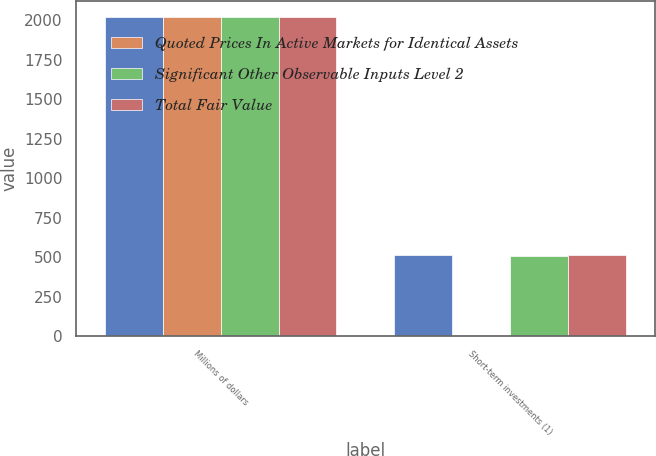Convert chart. <chart><loc_0><loc_0><loc_500><loc_500><stacked_bar_chart><ecel><fcel>Millions of dollars<fcel>Short-term investments (1)<nl><fcel>nan<fcel>2018<fcel>511<nl><fcel>Quoted Prices In Active Markets for Identical Assets<fcel>2018<fcel>5<nl><fcel>Significant Other Observable Inputs Level 2<fcel>2018<fcel>506<nl><fcel>Total Fair Value<fcel>2018<fcel>511<nl></chart> 